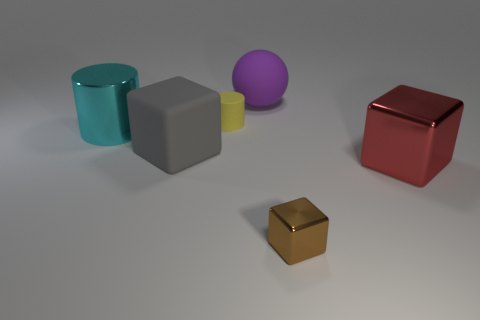What number of other things are made of the same material as the small cylinder?
Your response must be concise. 2. What number of tiny cylinders are to the left of the gray rubber block?
Your answer should be compact. 0. Is there any other thing that has the same size as the gray matte object?
Your response must be concise. Yes. What color is the block that is the same material as the sphere?
Offer a terse response. Gray. Is the large gray matte thing the same shape as the red thing?
Your response must be concise. Yes. How many metallic things are both in front of the red block and behind the large red thing?
Provide a short and direct response. 0. How many rubber things are either large gray objects or big blue cylinders?
Your answer should be compact. 1. What is the size of the metallic cube in front of the big cube that is right of the large sphere?
Your response must be concise. Small. Are there any objects on the left side of the cylinder that is on the right side of the large cube on the left side of the large purple ball?
Give a very brief answer. Yes. Is the large cube that is right of the matte cube made of the same material as the cylinder that is left of the yellow matte thing?
Keep it short and to the point. Yes. 